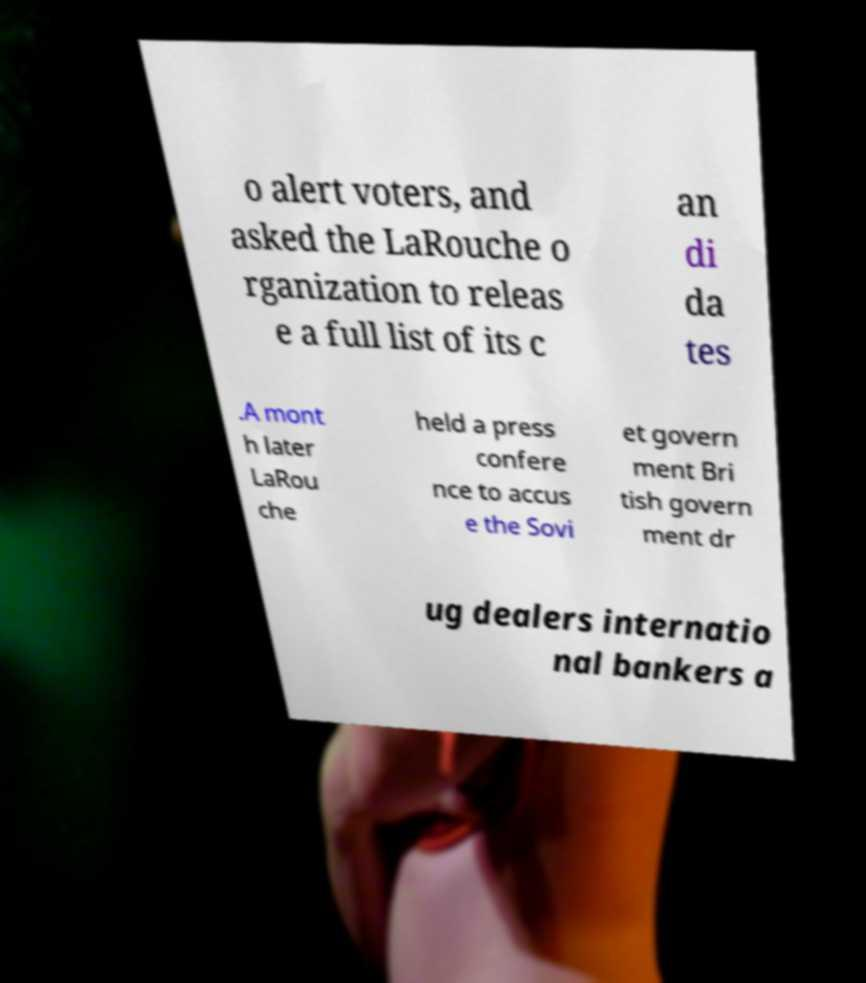Could you assist in decoding the text presented in this image and type it out clearly? o alert voters, and asked the LaRouche o rganization to releas e a full list of its c an di da tes .A mont h later LaRou che held a press confere nce to accus e the Sovi et govern ment Bri tish govern ment dr ug dealers internatio nal bankers a 